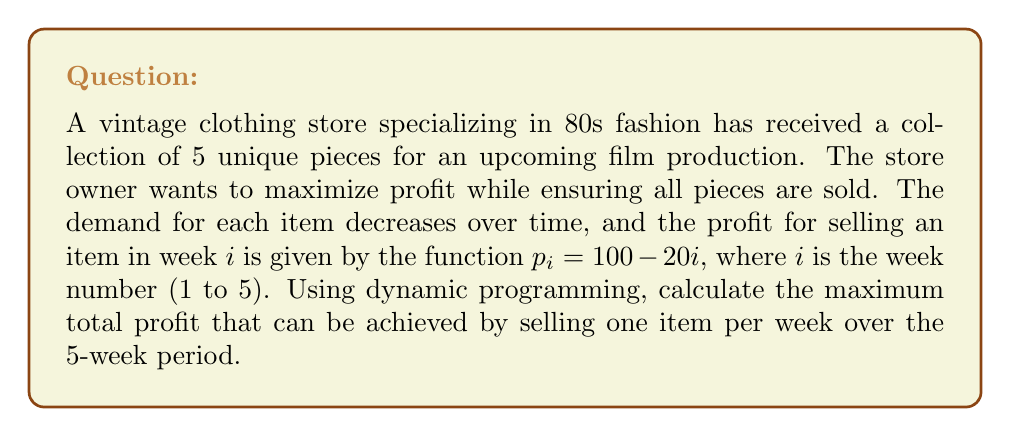Teach me how to tackle this problem. To solve this problem using dynamic programming, we'll follow these steps:

1) Define the subproblem:
   Let $DP[i][j]$ be the maximum profit that can be achieved by selling $j$ items in the first $i$ weeks.

2) Establish the recurrence relation:
   For each week $i$ and number of items sold $j$, we have two choices:
   a) Sell an item this week: $DP[i][j] = p_i + DP[i-1][j-1]$
   b) Don't sell an item this week: $DP[i][j] = DP[i-1][j]$
   We take the maximum of these two options.

3) Initialize the base cases:
   $DP[0][j] = 0$ for all $j$ (no profit if no weeks)
   $DP[i][0] = 0$ for all $i$ (no profit if no items sold)

4) Fill the DP table:
   For $i$ from 1 to 5 and $j$ from 1 to 5:
   $$DP[i][j] = \max(100 - 20i + DP[i-1][j-1], DP[i-1][j])$$

5) The final answer will be $DP[5][5]$

Let's fill the DP table:

$$
\begin{array}{c|ccccc}
i\backslash j & 0 & 1 & 2 & 3 & 4 & 5 \\
\hline
0 & 0 & 0 & 0 & 0 & 0 & 0 \\
1 & 0 & 80 & 80 & 80 & 80 & 80 \\
2 & 0 & 80 & 140 & 140 & 140 & 140 \\
3 & 0 & 80 & 140 & 180 & 180 & 180 \\
4 & 0 & 80 & 140 & 180 & 200 & 200 \\
5 & 0 & 80 & 140 & 180 & 200 & 200 \\
\end{array}
$$

The maximum profit that can be achieved is $DP[5][5] = 200$.

This corresponds to selling items in weeks 1, 2, 3, and 4, with profits of 80, 60, 40, and 20 respectively.
Answer: The maximum total profit that can be achieved by selling one item per week over the 5-week period is $200. 